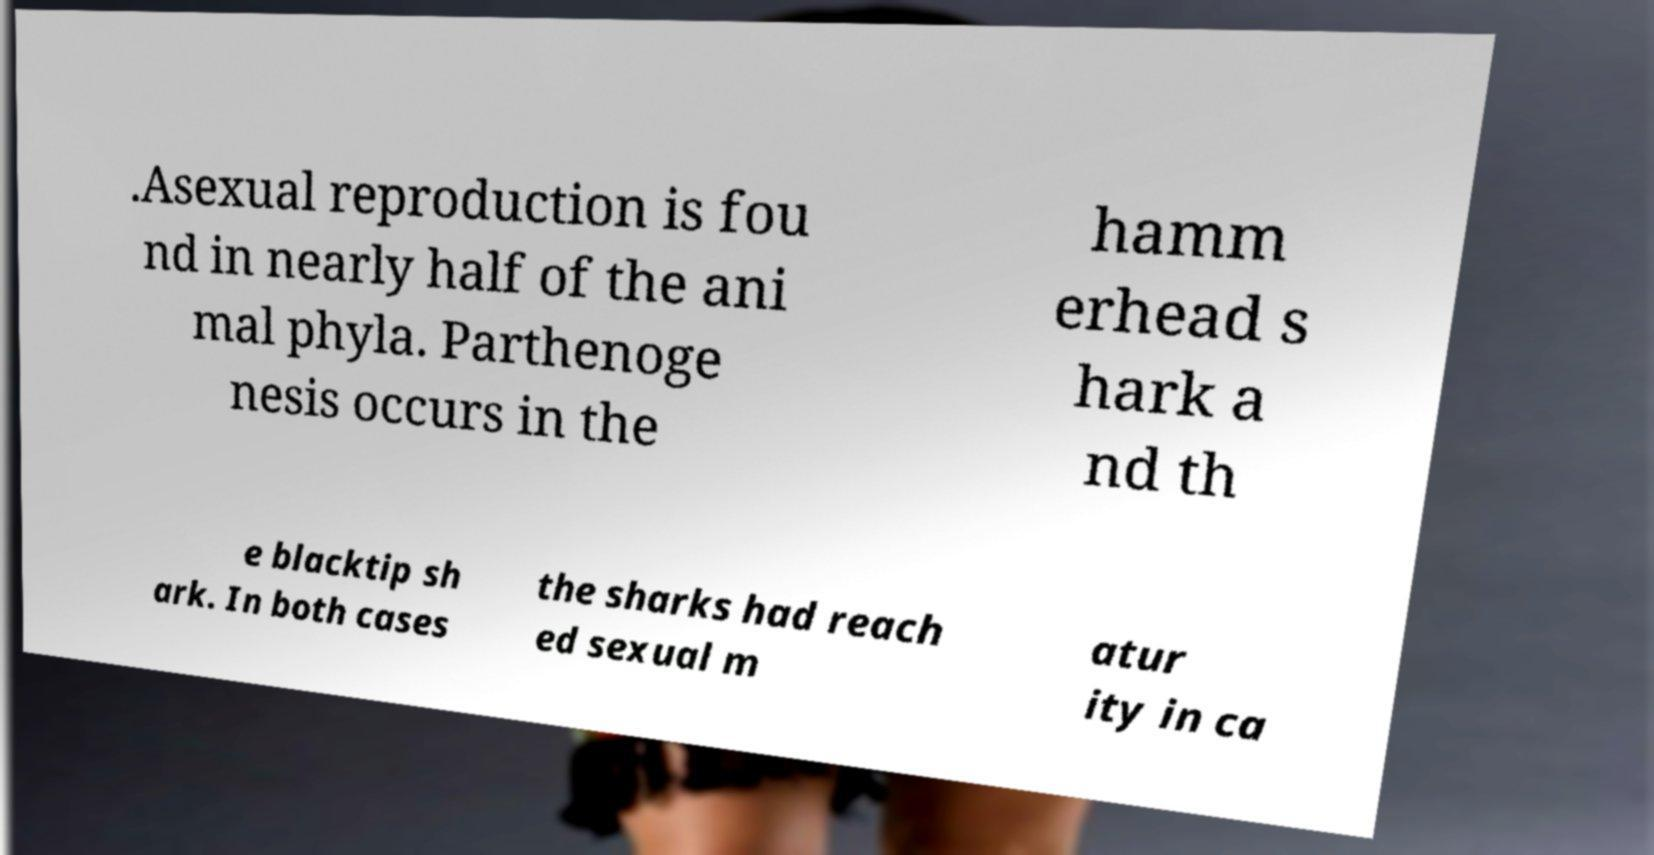Could you assist in decoding the text presented in this image and type it out clearly? .Asexual reproduction is fou nd in nearly half of the ani mal phyla. Parthenoge nesis occurs in the hamm erhead s hark a nd th e blacktip sh ark. In both cases the sharks had reach ed sexual m atur ity in ca 